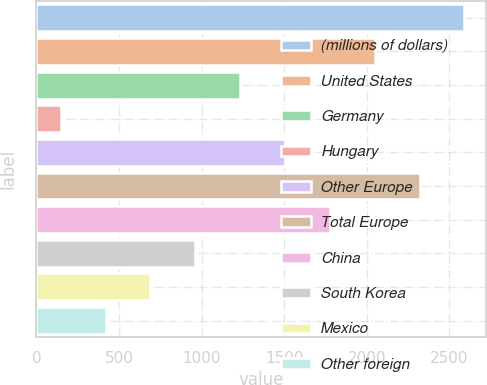<chart> <loc_0><loc_0><loc_500><loc_500><bar_chart><fcel>(millions of dollars)<fcel>United States<fcel>Germany<fcel>Hungary<fcel>Other Europe<fcel>Total Europe<fcel>China<fcel>South Korea<fcel>Mexico<fcel>Other foreign<nl><fcel>2592.17<fcel>2048.91<fcel>1234.02<fcel>147.5<fcel>1505.65<fcel>2320.54<fcel>1777.28<fcel>962.39<fcel>690.76<fcel>419.13<nl></chart> 